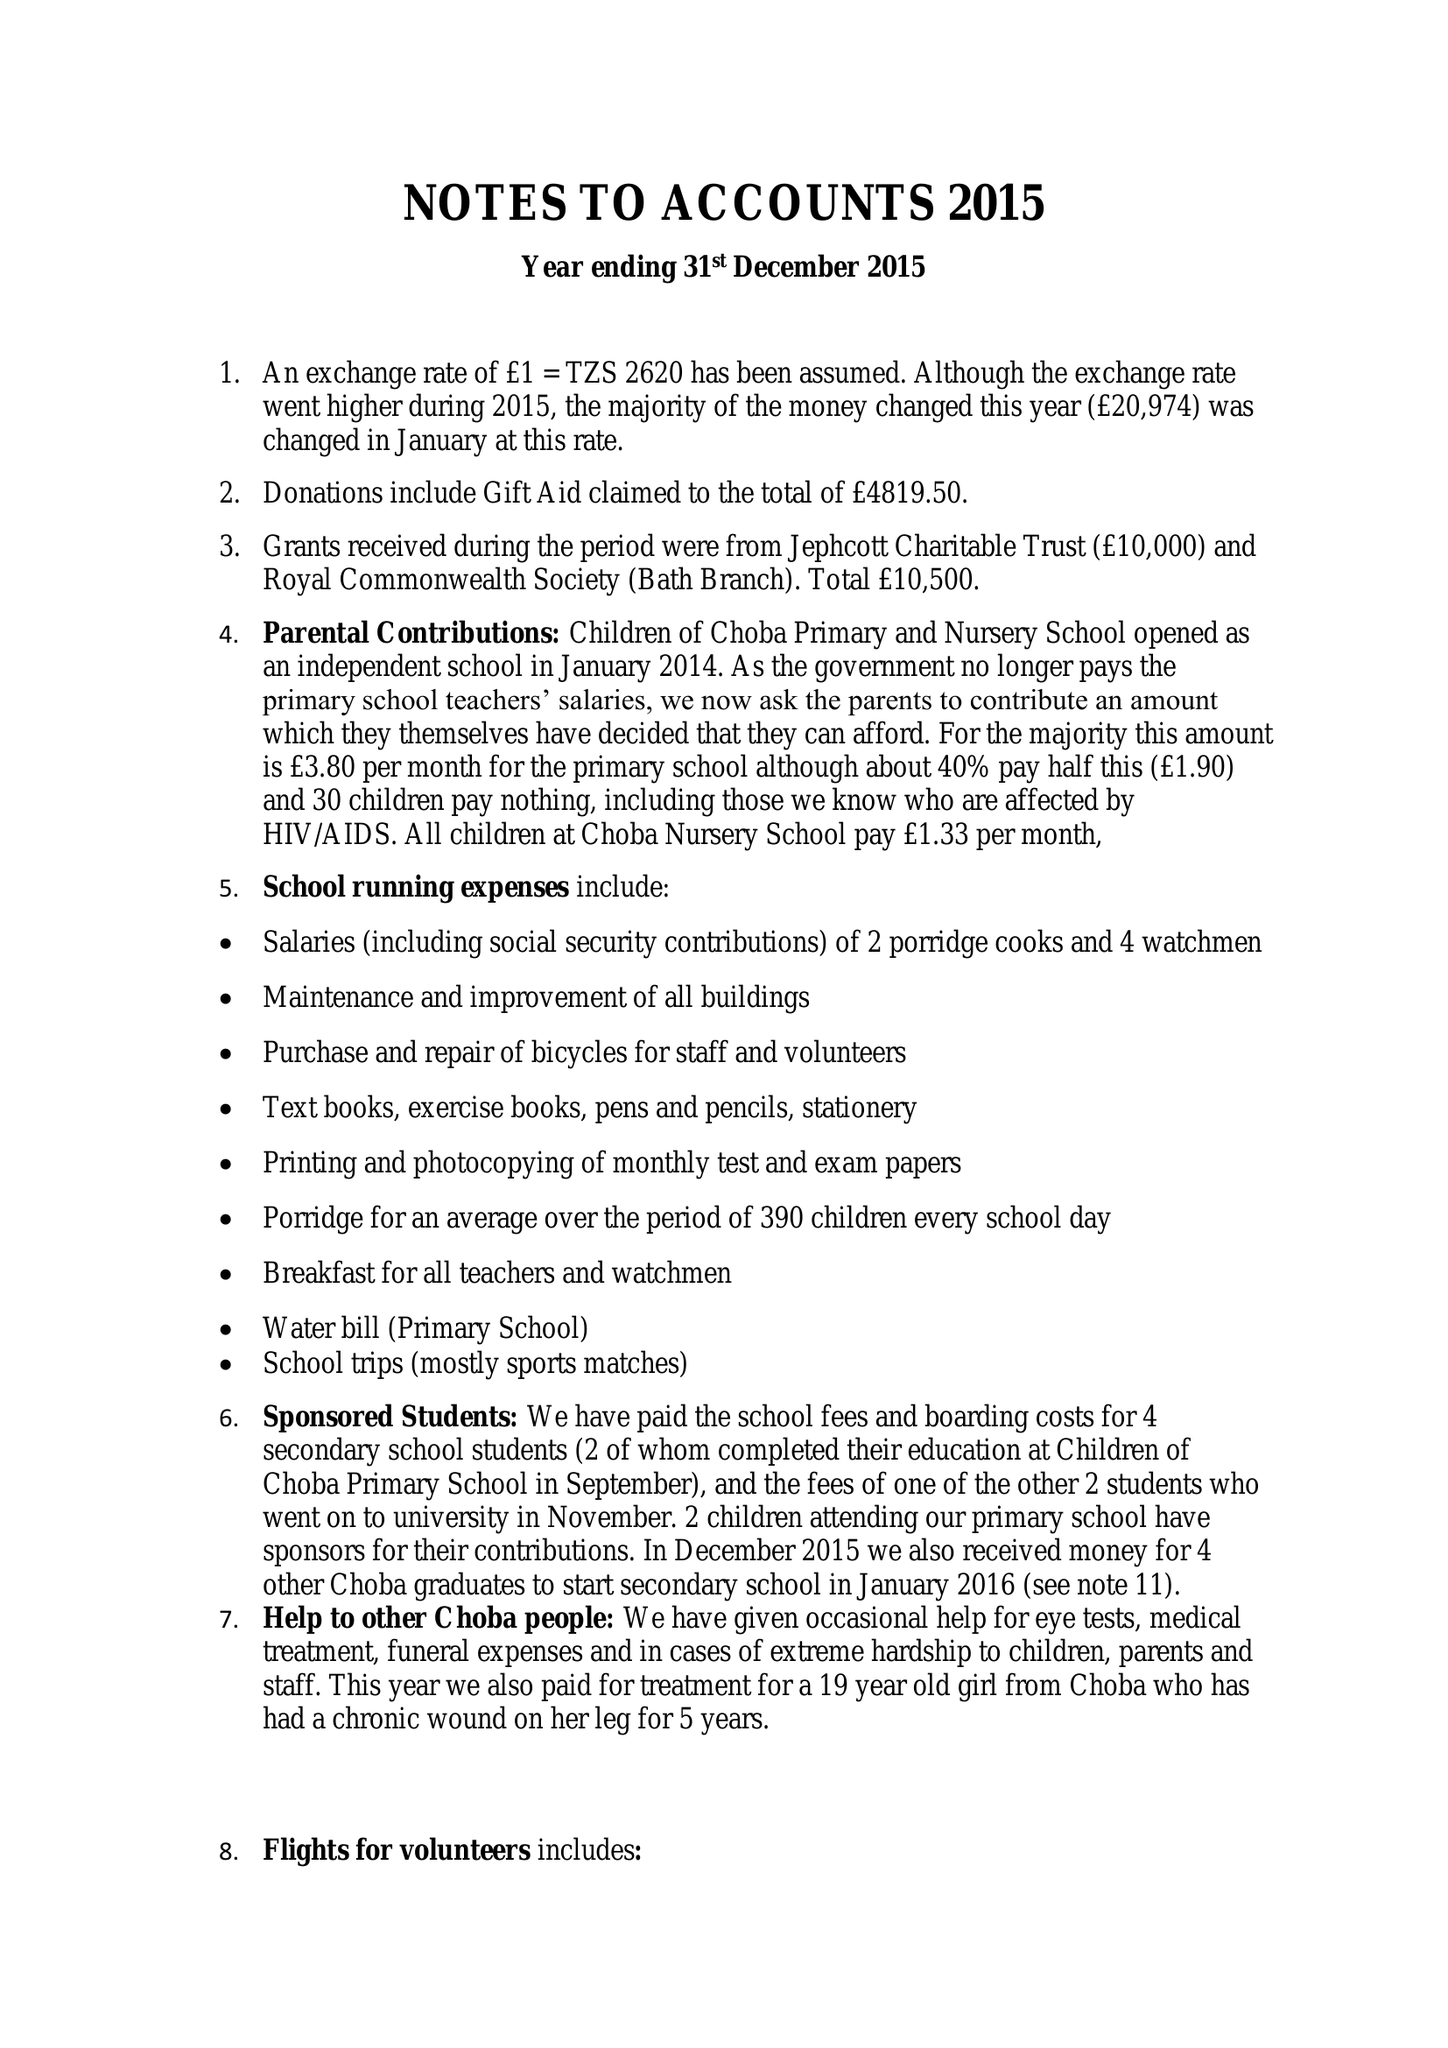What is the value for the address__street_line?
Answer the question using a single word or phrase. 20 HORSESHOE WALK 